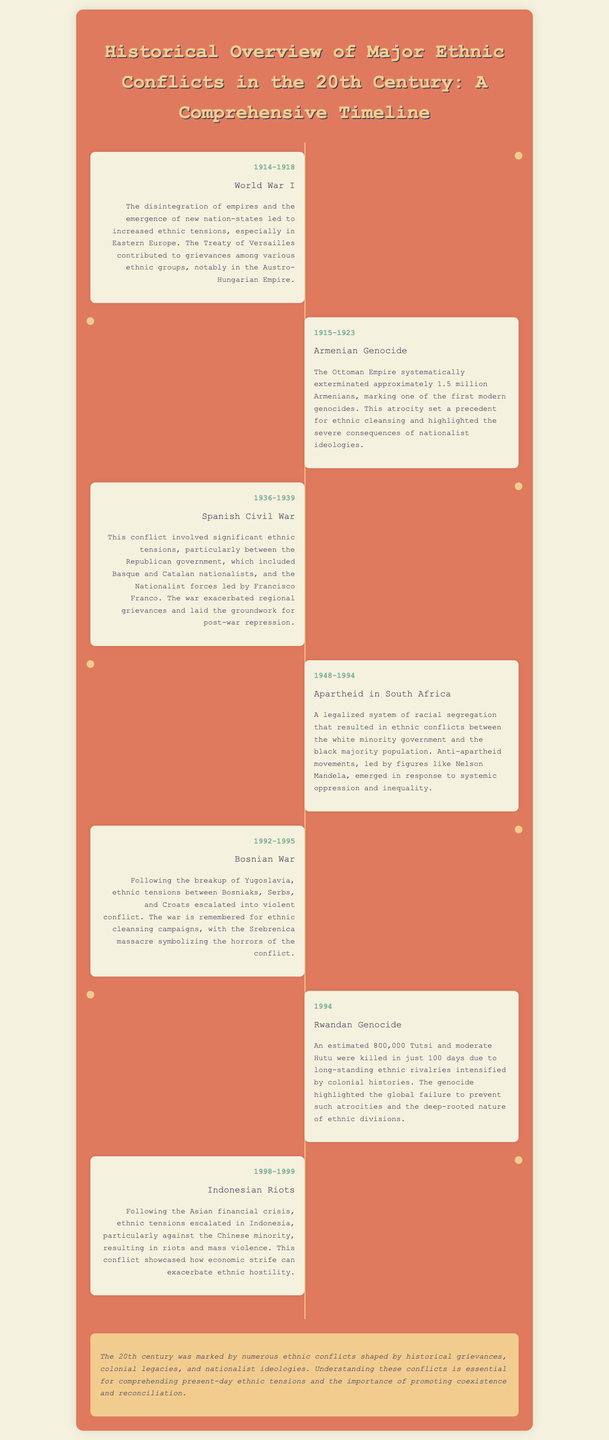What event occurred from 1914 to 1918? The document states that World War I occurred during this time, contributing to ethnic tensions.
Answer: World War I How many Armenians were killed during the Armenian Genocide? The document specifies that approximately 1.5 million Armenians were systematically exterminated.
Answer: 1.5 million What was a major conflict in Spain between 1936 and 1939? The document highlights the Spanish Civil War as a significant conflict during these years.
Answer: Spanish Civil War Which system of segregation lasted from 1948 to 1994 in South Africa? The document refers to Apartheid as the system that caused ethnic conflicts during this period.
Answer: Apartheid What massacre symbolized the horrors of the Bosnian War? The document mentions the Srebrenica massacre as a key event that exemplified the conflict's violence.
Answer: Srebrenica massacre What was a key factor leading to the Rwandan Genocide in 1994? The document indicates that long-standing ethnic rivalries and colonial histories intensified the violence.
Answer: Ethnic rivalries What economic event preceded the Indonesian Riots of 1998-1999? The document notes that the Asian financial crisis led to increased ethnic tensions and violence in Indonesia.
Answer: Asian financial crisis What overarching theme is mentioned regarding the conflicts of the 20th century? The conclusion emphasizes the role of historical grievances, colonial legacies, and nationalist ideologies.
Answer: Historical grievances Which prominent anti-apartheid leader is mentioned in the context of ethnic conflict in South Africa? The document highlights Nelson Mandela as a significant figure in the anti-apartheid movements.
Answer: Nelson Mandela 